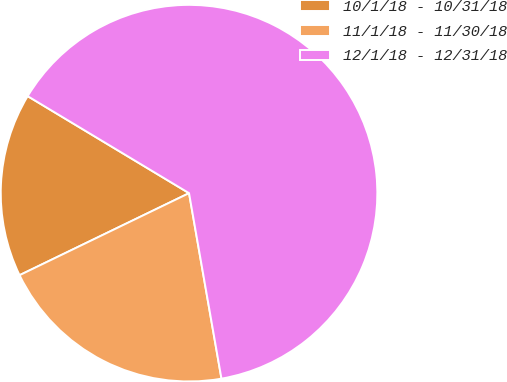Convert chart. <chart><loc_0><loc_0><loc_500><loc_500><pie_chart><fcel>10/1/18 - 10/31/18<fcel>11/1/18 - 11/30/18<fcel>12/1/18 - 12/31/18<nl><fcel>15.79%<fcel>20.58%<fcel>63.63%<nl></chart> 